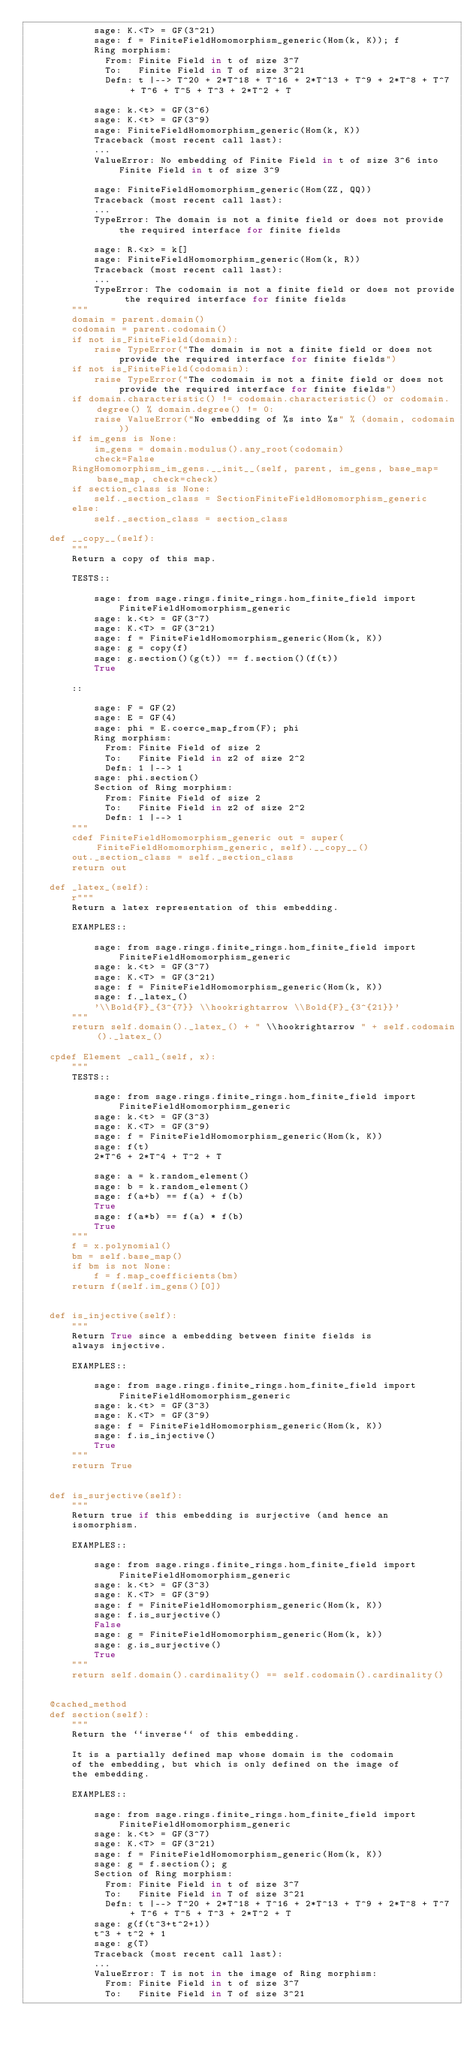<code> <loc_0><loc_0><loc_500><loc_500><_Cython_>            sage: K.<T> = GF(3^21)
            sage: f = FiniteFieldHomomorphism_generic(Hom(k, K)); f
            Ring morphism:
              From: Finite Field in t of size 3^7
              To:   Finite Field in T of size 3^21
              Defn: t |--> T^20 + 2*T^18 + T^16 + 2*T^13 + T^9 + 2*T^8 + T^7 + T^6 + T^5 + T^3 + 2*T^2 + T

            sage: k.<t> = GF(3^6)
            sage: K.<t> = GF(3^9)
            sage: FiniteFieldHomomorphism_generic(Hom(k, K))
            Traceback (most recent call last):
            ...
            ValueError: No embedding of Finite Field in t of size 3^6 into Finite Field in t of size 3^9

            sage: FiniteFieldHomomorphism_generic(Hom(ZZ, QQ))
            Traceback (most recent call last):
            ...
            TypeError: The domain is not a finite field or does not provide the required interface for finite fields

            sage: R.<x> = k[]
            sage: FiniteFieldHomomorphism_generic(Hom(k, R))
            Traceback (most recent call last):
            ...
            TypeError: The codomain is not a finite field or does not provide the required interface for finite fields
        """
        domain = parent.domain()
        codomain = parent.codomain()
        if not is_FiniteField(domain):
            raise TypeError("The domain is not a finite field or does not provide the required interface for finite fields")
        if not is_FiniteField(codomain):
            raise TypeError("The codomain is not a finite field or does not provide the required interface for finite fields")
        if domain.characteristic() != codomain.characteristic() or codomain.degree() % domain.degree() != 0:
            raise ValueError("No embedding of %s into %s" % (domain, codomain))
        if im_gens is None:
            im_gens = domain.modulus().any_root(codomain)
            check=False
        RingHomomorphism_im_gens.__init__(self, parent, im_gens, base_map=base_map, check=check)
        if section_class is None:
            self._section_class = SectionFiniteFieldHomomorphism_generic
        else:
            self._section_class = section_class

    def __copy__(self):
        """
        Return a copy of this map.

        TESTS::

            sage: from sage.rings.finite_rings.hom_finite_field import FiniteFieldHomomorphism_generic
            sage: k.<t> = GF(3^7)
            sage: K.<T> = GF(3^21)
            sage: f = FiniteFieldHomomorphism_generic(Hom(k, K))
            sage: g = copy(f)
            sage: g.section()(g(t)) == f.section()(f(t))
            True

        ::

            sage: F = GF(2)
            sage: E = GF(4)
            sage: phi = E.coerce_map_from(F); phi
            Ring morphism:
              From: Finite Field of size 2
              To:   Finite Field in z2 of size 2^2
              Defn: 1 |--> 1
            sage: phi.section()
            Section of Ring morphism:
              From: Finite Field of size 2
              To:   Finite Field in z2 of size 2^2
              Defn: 1 |--> 1
        """
        cdef FiniteFieldHomomorphism_generic out = super(FiniteFieldHomomorphism_generic, self).__copy__()
        out._section_class = self._section_class
        return out

    def _latex_(self):
        r"""
        Return a latex representation of this embedding.

        EXAMPLES::

            sage: from sage.rings.finite_rings.hom_finite_field import FiniteFieldHomomorphism_generic
            sage: k.<t> = GF(3^7)
            sage: K.<T> = GF(3^21)
            sage: f = FiniteFieldHomomorphism_generic(Hom(k, K))
            sage: f._latex_()
            '\\Bold{F}_{3^{7}} \\hookrightarrow \\Bold{F}_{3^{21}}'
        """
        return self.domain()._latex_() + " \\hookrightarrow " + self.codomain()._latex_()

    cpdef Element _call_(self, x):
        """
        TESTS::

            sage: from sage.rings.finite_rings.hom_finite_field import FiniteFieldHomomorphism_generic
            sage: k.<t> = GF(3^3)
            sage: K.<T> = GF(3^9)
            sage: f = FiniteFieldHomomorphism_generic(Hom(k, K))
            sage: f(t)
            2*T^6 + 2*T^4 + T^2 + T

            sage: a = k.random_element()
            sage: b = k.random_element()
            sage: f(a+b) == f(a) + f(b)
            True
            sage: f(a*b) == f(a) * f(b)
            True
        """
        f = x.polynomial()
        bm = self.base_map()
        if bm is not None:
            f = f.map_coefficients(bm)
        return f(self.im_gens()[0])


    def is_injective(self):
        """
        Return True since a embedding between finite fields is
        always injective.

        EXAMPLES::

            sage: from sage.rings.finite_rings.hom_finite_field import FiniteFieldHomomorphism_generic
            sage: k.<t> = GF(3^3)
            sage: K.<T> = GF(3^9)
            sage: f = FiniteFieldHomomorphism_generic(Hom(k, K))
            sage: f.is_injective()
            True
        """
        return True


    def is_surjective(self):
        """
        Return true if this embedding is surjective (and hence an
        isomorphism.

        EXAMPLES::

            sage: from sage.rings.finite_rings.hom_finite_field import FiniteFieldHomomorphism_generic
            sage: k.<t> = GF(3^3)
            sage: K.<T> = GF(3^9)
            sage: f = FiniteFieldHomomorphism_generic(Hom(k, K))
            sage: f.is_surjective()
            False
            sage: g = FiniteFieldHomomorphism_generic(Hom(k, k))
            sage: g.is_surjective()
            True
        """
        return self.domain().cardinality() == self.codomain().cardinality()


    @cached_method
    def section(self):
        """
        Return the ``inverse`` of this embedding.

        It is a partially defined map whose domain is the codomain
        of the embedding, but which is only defined on the image of
        the embedding.

        EXAMPLES::

            sage: from sage.rings.finite_rings.hom_finite_field import FiniteFieldHomomorphism_generic
            sage: k.<t> = GF(3^7)
            sage: K.<T> = GF(3^21)
            sage: f = FiniteFieldHomomorphism_generic(Hom(k, K))
            sage: g = f.section(); g
            Section of Ring morphism:
              From: Finite Field in t of size 3^7
              To:   Finite Field in T of size 3^21
              Defn: t |--> T^20 + 2*T^18 + T^16 + 2*T^13 + T^9 + 2*T^8 + T^7 + T^6 + T^5 + T^3 + 2*T^2 + T
            sage: g(f(t^3+t^2+1))
            t^3 + t^2 + 1
            sage: g(T)
            Traceback (most recent call last):
            ...
            ValueError: T is not in the image of Ring morphism:
              From: Finite Field in t of size 3^7
              To:   Finite Field in T of size 3^21</code> 